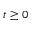<formula> <loc_0><loc_0><loc_500><loc_500>t \geq 0</formula> 